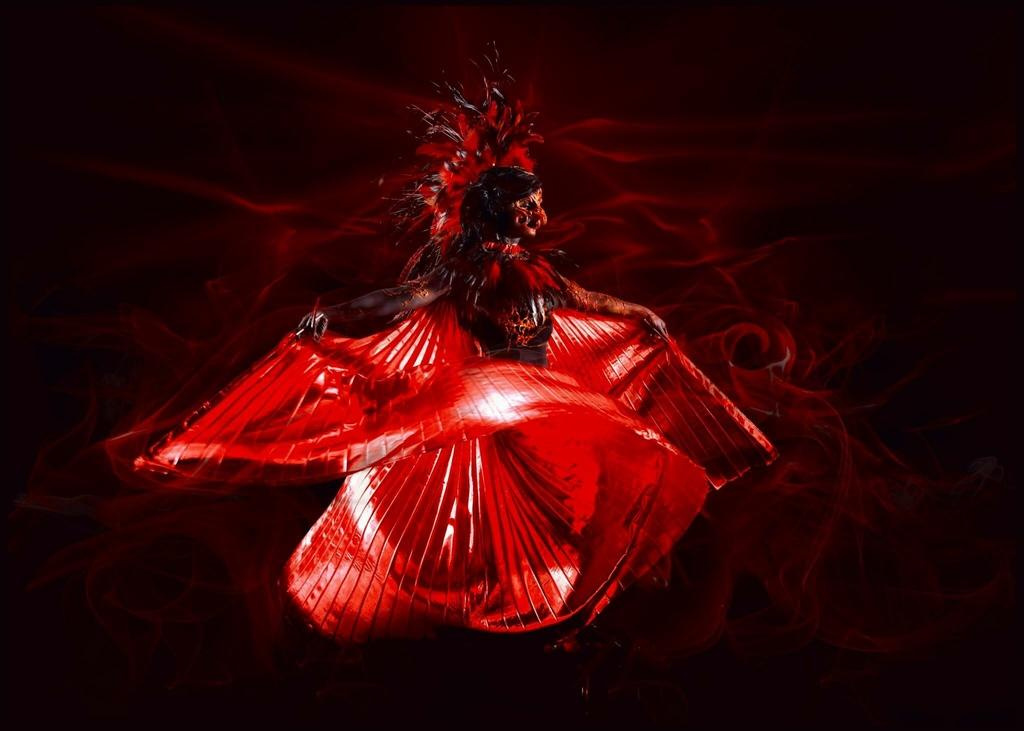What is the main subject of the image? There is a painting in the image. What is the painting depicting? The painting depicts a dancing woman. What color is the woman wearing in the painting? The woman in the painting is wearing red. How many ladybugs can be seen on the woman's dress in the painting? There are no ladybugs present on the woman's dress in the painting. Can you tell me if the painting comes with a receipt? There is no mention of a receipt in the image or the provided facts. 